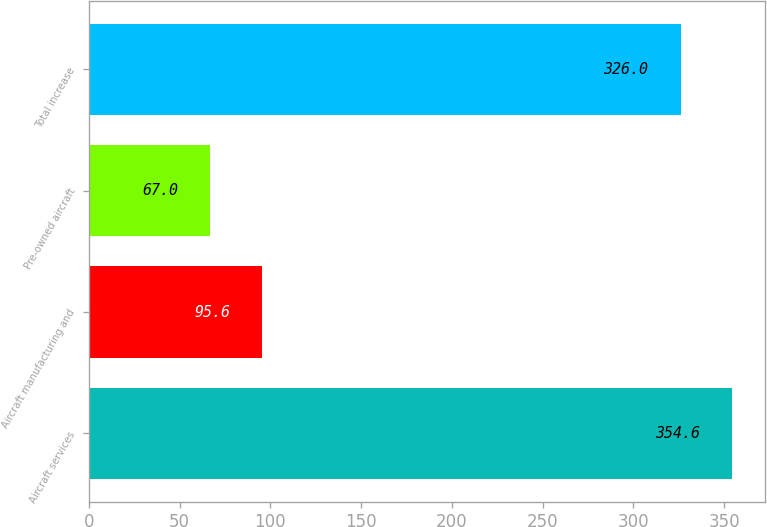<chart> <loc_0><loc_0><loc_500><loc_500><bar_chart><fcel>Aircraft services<fcel>Aircraft manufacturing and<fcel>Pre-owned aircraft<fcel>Total increase<nl><fcel>354.6<fcel>95.6<fcel>67<fcel>326<nl></chart> 